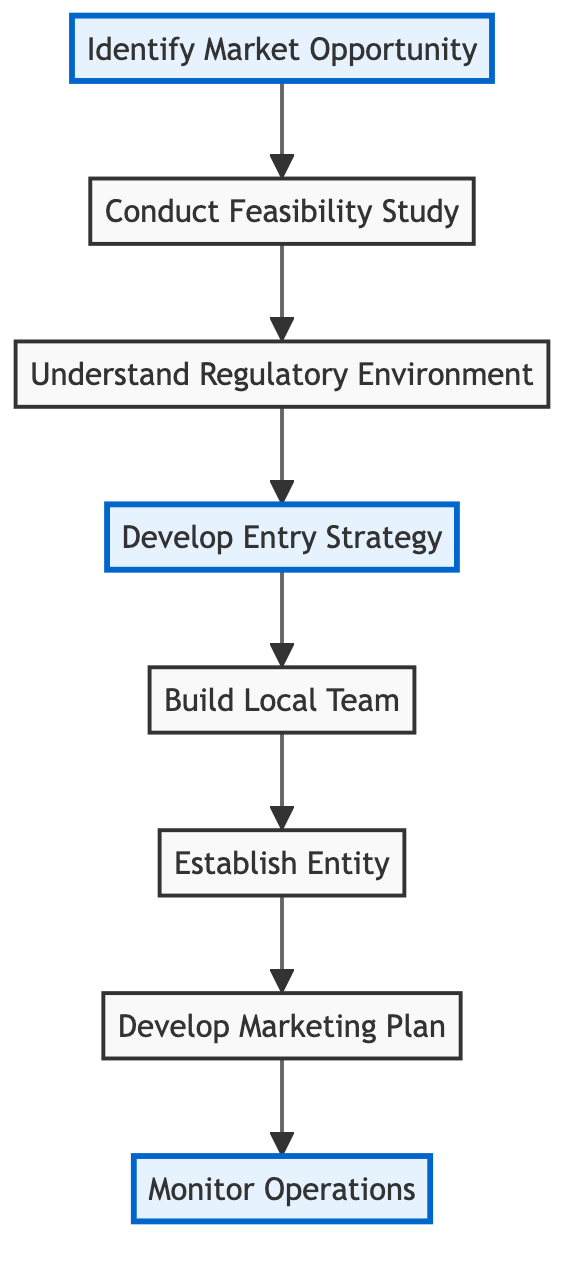What is the first step in the market entry strategy? The first step, as represented at the top of the diagram, is "Identify Market Opportunity." This node initiates the flow of the process.
Answer: Identify Market Opportunity How many total nodes are present in the diagram? The diagram lists a total of 8 unique nodes, detailing different stages of the market entry strategy.
Answer: 8 What comes after "Conduct Feasibility Study"? The relationship shows that "Understand Regulatory Environment" is the next step that follows "Conduct Feasibility Study."
Answer: Understand Regulatory Environment What is the last step in the diagram? The final step depicted at the end of the flow is "Monitor Operations," which encompasses ongoing assessment after marketing efforts.
Answer: Monitor Operations Which steps are highlighted in the diagram? The highlighted nodes are "Identify Market Opportunity," "Develop Entry Strategy," and "Monitor Operations," indicating they may represent crucial points in the strategy.
Answer: Identify Market Opportunity, Develop Entry Strategy, Monitor Operations How many edges connect the nodes in this diagram? The diagram illustrates 7 edges that represent the flow from one step to the next, outlining the connections between various actions in the strategy.
Answer: 7 What is the relationship between "Build Local Team" and "Establish Entity"? The "Build Local Team" node directly leads to "Establish Entity," indicating that building a team is a prerequisite for legally establishing the business in China.
Answer: Build Local Team leads to Establish Entity Which step develops a tailored marketing strategy? The node that specifies the creation of a tailored marketing strategy is "Develop Marketing Plan," which follows the establishment of the business entity.
Answer: Develop Marketing Plan 